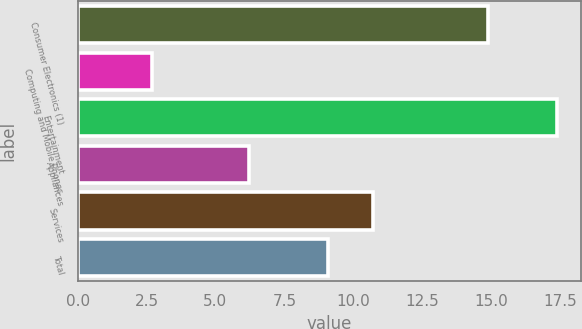Convert chart to OTSL. <chart><loc_0><loc_0><loc_500><loc_500><bar_chart><fcel>Consumer Electronics (1)<fcel>Computing and Mobile Phones<fcel>Entertainment<fcel>Appliances<fcel>Services<fcel>Total<nl><fcel>14.9<fcel>2.7<fcel>17.4<fcel>6.2<fcel>10.7<fcel>9.1<nl></chart> 